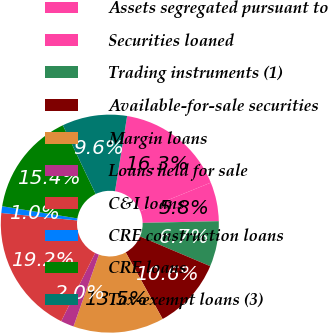<chart> <loc_0><loc_0><loc_500><loc_500><pie_chart><fcel>Assets segregated pursuant to<fcel>Securities loaned<fcel>Trading instruments (1)<fcel>Available-for-sale securities<fcel>Margin loans<fcel>Loans held for sale<fcel>C&I loans<fcel>CRE construction loans<fcel>CRE loans<fcel>Tax-exempt loans (3)<nl><fcel>16.32%<fcel>5.78%<fcel>6.74%<fcel>10.57%<fcel>13.45%<fcel>1.95%<fcel>19.2%<fcel>0.99%<fcel>15.36%<fcel>9.62%<nl></chart> 